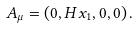Convert formula to latex. <formula><loc_0><loc_0><loc_500><loc_500>A _ { \mu } = \left ( 0 , H x _ { 1 } , 0 , 0 \right ) .</formula> 